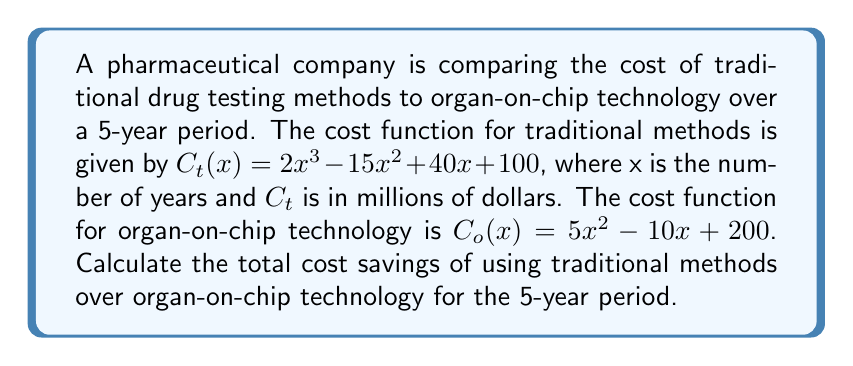Show me your answer to this math problem. To solve this problem, we need to follow these steps:

1) Calculate the cost of traditional methods over 5 years:
   $C_t(5) = 2(5^3) - 15(5^2) + 40(5) + 100$
   $= 2(125) - 15(25) + 200 + 100$
   $= 250 - 375 + 300$
   $= 175$ million dollars

2) Calculate the cost of organ-on-chip technology over 5 years:
   $C_o(5) = 5(5^2) - 10(5) + 200$
   $= 5(25) - 50 + 200$
   $= 125 - 50 + 200$
   $= 275$ million dollars

3) Calculate the difference to find the cost savings:
   Cost savings = $C_o(5) - C_t(5)$
   $= 275 - 175 = 100$ million dollars

Therefore, the total cost savings of using traditional methods over organ-on-chip technology for the 5-year period is $100 million.
Answer: $100 million 